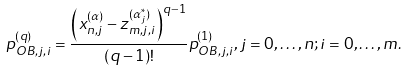<formula> <loc_0><loc_0><loc_500><loc_500>p _ { O B , j , i } ^ { ( q ) } = \frac { { { { \left ( x _ { n , j } ^ { ( \alpha ) } - z _ { m , j , i } ^ { ( \alpha _ { j } ^ { * } ) } \right ) } ^ { q - 1 } } } } { ( q - 1 ) ! } p _ { O B , j , i } ^ { ( 1 ) } , j = 0 , \dots , n ; i = 0 , \dots , m .</formula> 